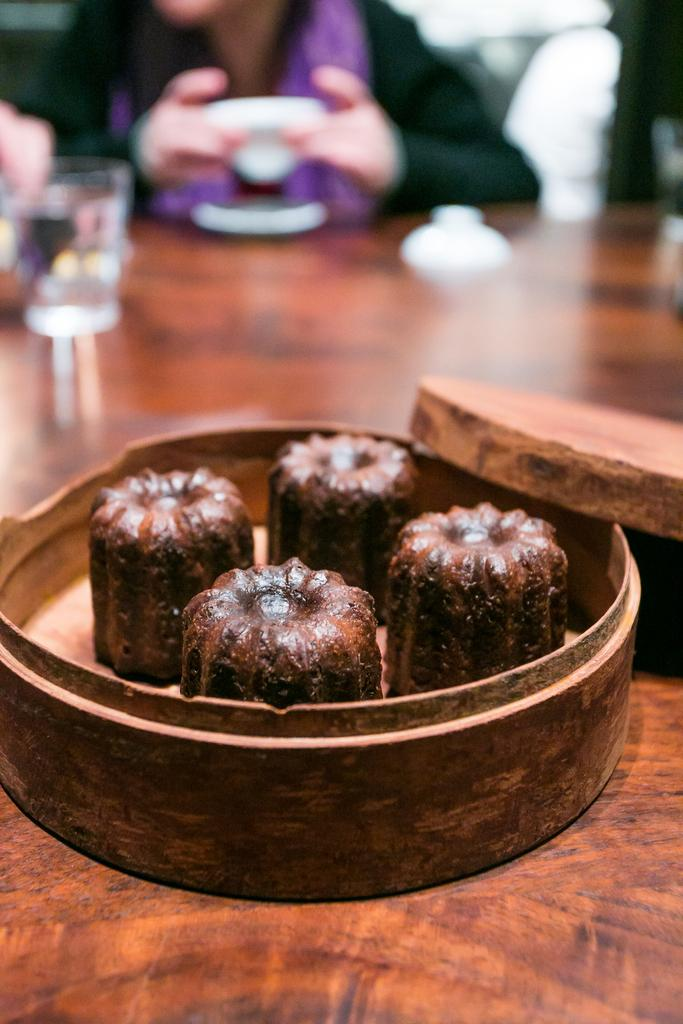What is the main object in the image? There is a table in the image. What is on the table? There are boxes on the table. What is inside the boxes? The boxes contain eatables. Where is the person in the image located? The person is positioned at the top of the image. How does the person in the image cause the wave to burst? There is no wave or bursting event in the image; it features a table with boxes containing eatables and a person positioned at the top. 